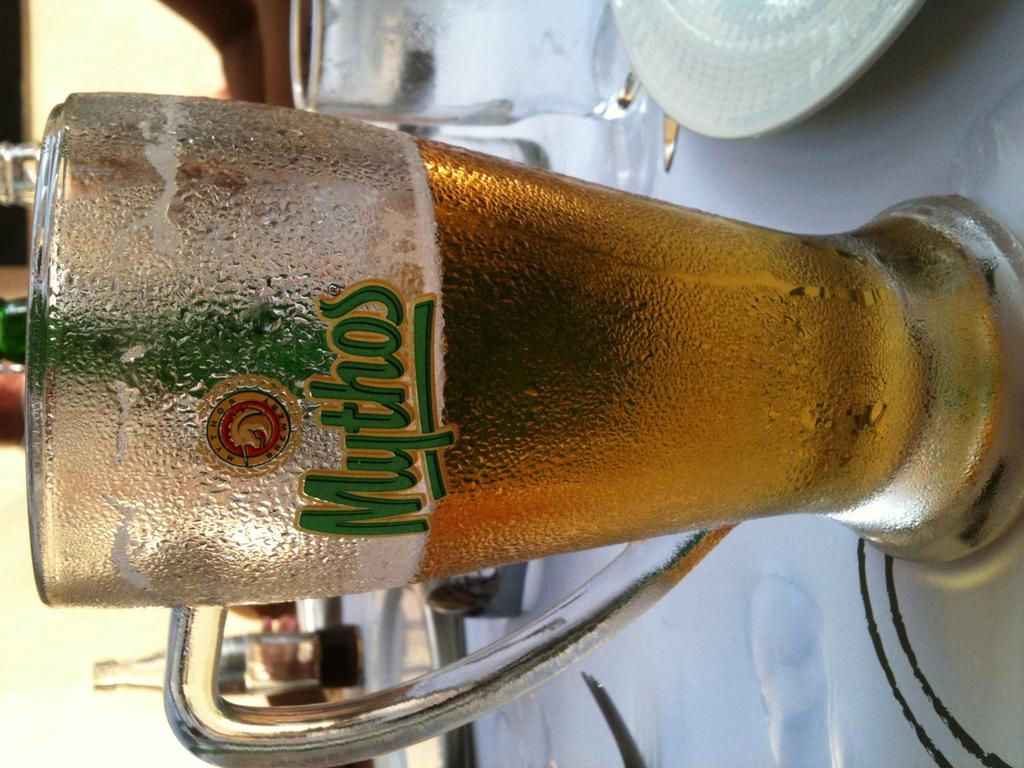What is the main object on the table in the image? There is a plate in the image. What other objects can be seen on the table? There are glasses, bottles, and a fork visible on the table. What is the purpose of the fork in the image? The fork is likely used for eating or serving food. Can you describe any objects visible in the background of the image? Unfortunately, the provided facts do not give any information about the objects in the background. What type of reward is the person receiving in the image? There is no person or reward present in the image; it only shows objects placed on a table. Can you describe the face of the person in the image? There is no person present in the image, so we cannot describe their face. 